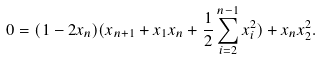<formula> <loc_0><loc_0><loc_500><loc_500>0 = ( 1 - 2 x _ { n } ) ( x _ { n + 1 } + x _ { 1 } x _ { n } + \frac { 1 } { 2 } \sum _ { i = 2 } ^ { n - 1 } x _ { i } ^ { 2 } ) + x _ { n } x _ { 2 } ^ { 2 } .</formula> 